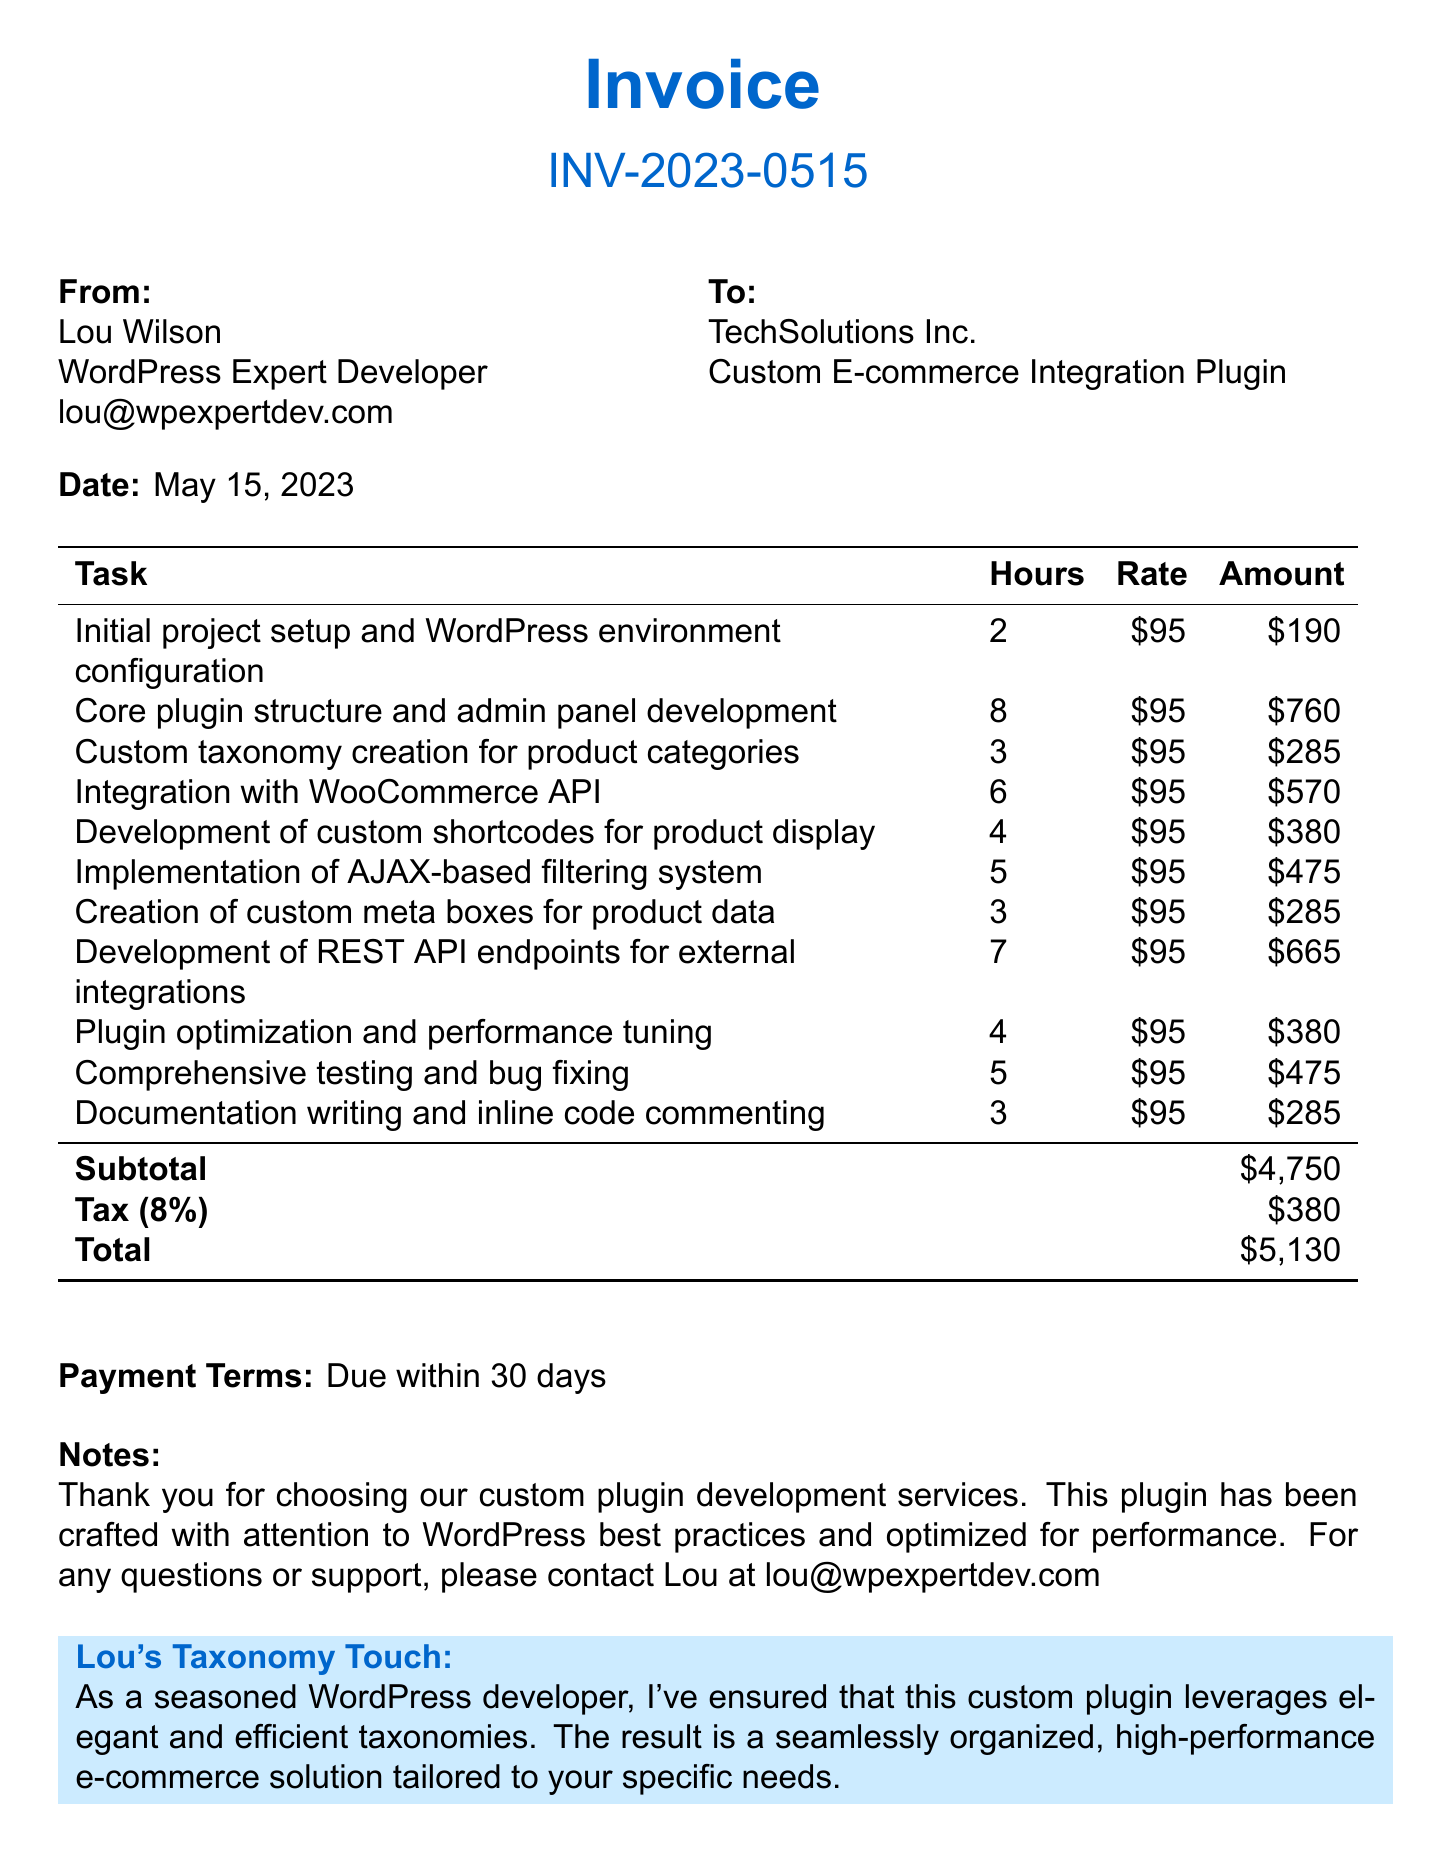What is the client name? The client name is listed at the top of the document as TechSolutions Inc.
Answer: TechSolutions Inc What is the invoice number? The invoice number is clearly stated in the header of the document.
Answer: INV-2023-0515 How many hours were spent on core plugin structure development? The document specifies the hours allocated to each task, including core plugin structure development.
Answer: 8 What is the total amount due? The total amount is calculated and shown at the end of the invoice, after including the tax.
Answer: 5,130 Which task involved custom taxonomy creation? The document lists various tasks, including one specifically for custom taxonomy creation.
Answer: Custom taxonomy creation for product categories How many hours were dedicated to comprehensive testing and bug fixing? The number of hours spent on each task is provided in the invoice, including comprehensive testing and bug fixing.
Answer: 5 What is the payment terms stated in the document? The payment terms are explicitly mentioned towards the end of the document.
Answer: Due within 30 days What percentage is the tax rate applied? The document lists the tax rate in relation to the subtotal of the services rendered.
Answer: 8% What is the rate per hour for the services? The hourly rate is stated beside each task listed in the document.
Answer: 95 